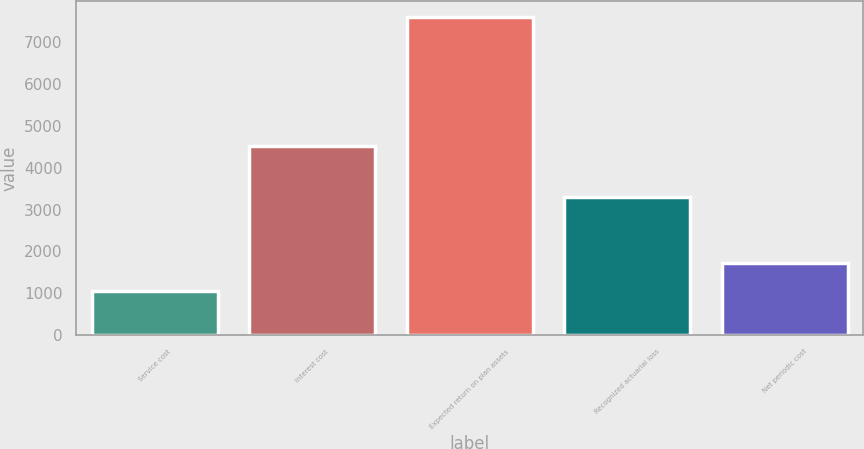Convert chart to OTSL. <chart><loc_0><loc_0><loc_500><loc_500><bar_chart><fcel>Service cost<fcel>Interest cost<fcel>Expected return on plan assets<fcel>Recognized actuarial loss<fcel>Net periodic cost<nl><fcel>1060<fcel>4528<fcel>7601<fcel>3305<fcel>1714.1<nl></chart> 